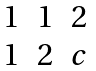<formula> <loc_0><loc_0><loc_500><loc_500>\begin{matrix} 1 & 1 & 2 \\ 1 & 2 & c \end{matrix}</formula> 